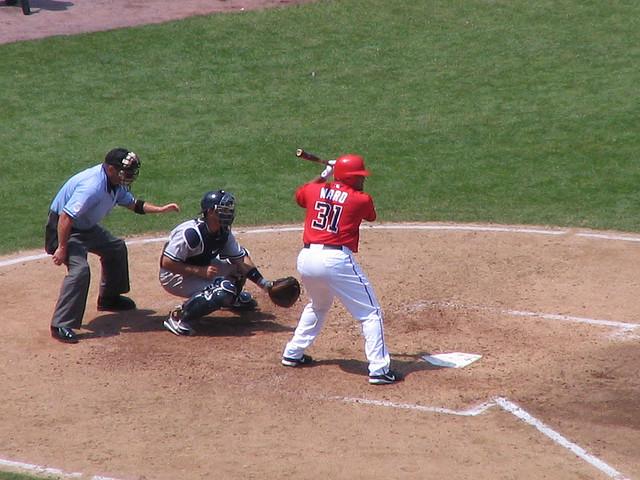What number is on the batters shirt?
Give a very brief answer. 31. Where are the players playing?
Quick response, please. Baseball field. What sport is being played?
Give a very brief answer. Baseball. What number is lee?
Concise answer only. 31. 